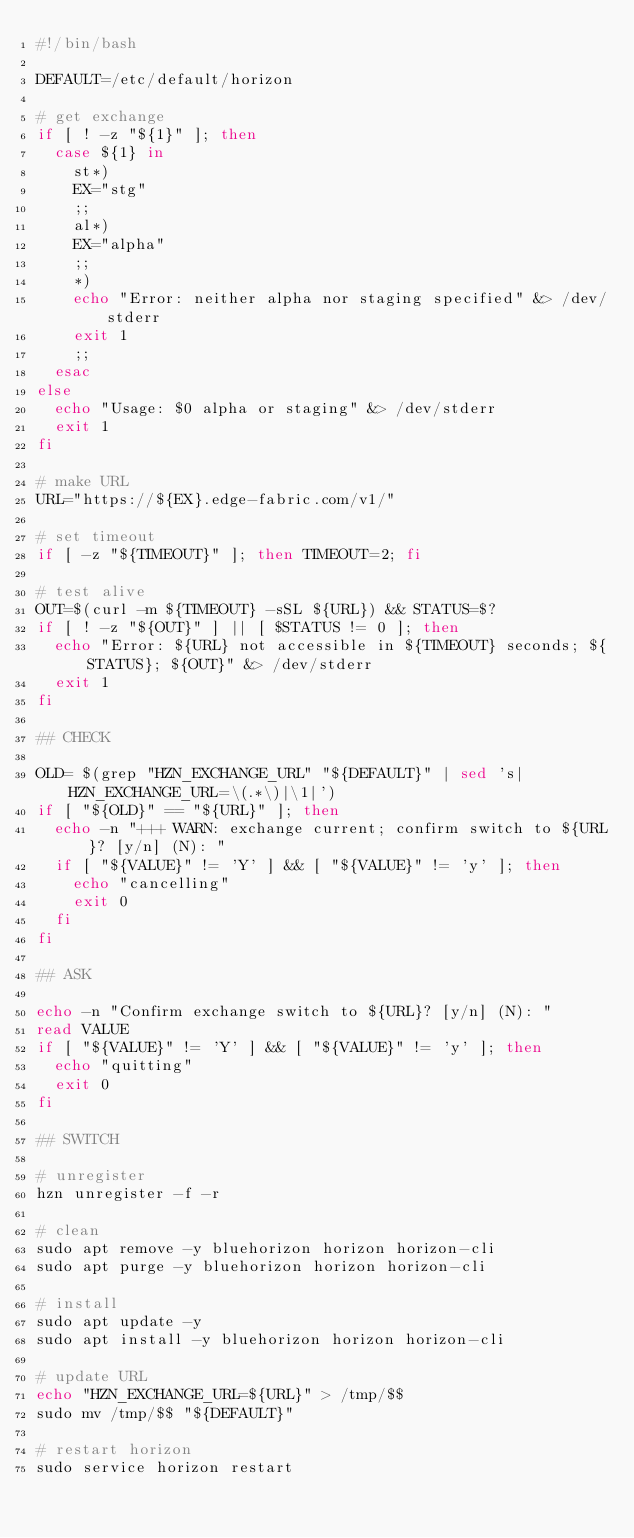Convert code to text. <code><loc_0><loc_0><loc_500><loc_500><_Bash_>#!/bin/bash

DEFAULT=/etc/default/horizon

# get exchange
if [ ! -z "${1}" ]; then
  case ${1} in
    st*)
	EX="stg"
	;;
    al*)
	EX="alpha"
	;;
    *)
	echo "Error: neither alpha nor staging specified" &> /dev/stderr
	exit 1
	;;
  esac
else
  echo "Usage: $0 alpha or staging" &> /dev/stderr
  exit 1
fi

# make URL
URL="https://${EX}.edge-fabric.com/v1/"

# set timeout
if [ -z "${TIMEOUT}" ]; then TIMEOUT=2; fi

# test alive
OUT=$(curl -m ${TIMEOUT} -sSL ${URL}) && STATUS=$?
if [ ! -z "${OUT}" ] || [ $STATUS != 0 ]; then
  echo "Error: ${URL} not accessible in ${TIMEOUT} seconds; ${STATUS}; ${OUT}" &> /dev/stderr
  exit 1
fi

## CHECK

OLD= $(grep "HZN_EXCHANGE_URL" "${DEFAULT}" | sed 's|HZN_EXCHANGE_URL=\(.*\)|\1|')
if [ "${OLD}" == "${URL}" ]; then
  echo -n "+++ WARN: exchange current; confirm switch to ${URL}? [y/n] (N): "
  if [ "${VALUE}" != 'Y' ] && [ "${VALUE}" != 'y' ]; then 
    echo "cancelling"
    exit 0
  fi
fi

## ASK

echo -n "Confirm exchange switch to ${URL}? [y/n] (N): "
read VALUE
if [ "${VALUE}" != 'Y' ] && [ "${VALUE}" != 'y' ]; then 
  echo "quitting"
  exit 0
fi

## SWITCH

# unregister
hzn unregister -f -r

# clean
sudo apt remove -y bluehorizon horizon horizon-cli
sudo apt purge -y bluehorizon horizon horizon-cli

# install
sudo apt update -y
sudo apt install -y bluehorizon horizon horizon-cli

# update URL
echo "HZN_EXCHANGE_URL=${URL}" > /tmp/$$
sudo mv /tmp/$$ "${DEFAULT}"

# restart horizon
sudo service horizon restart
</code> 